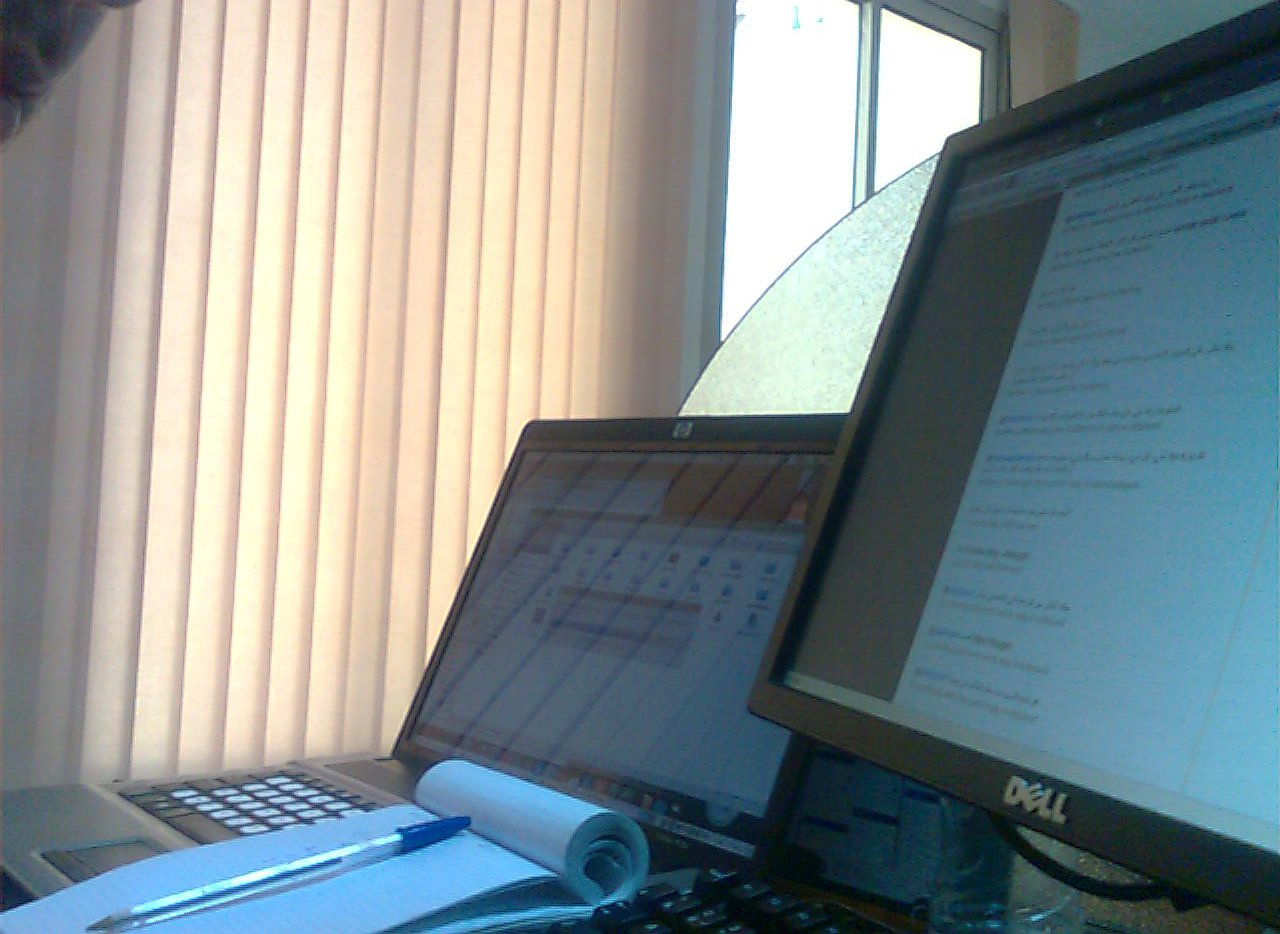What device is black? The computer monitor is black, with a sleek appearance prominent on the desk. 